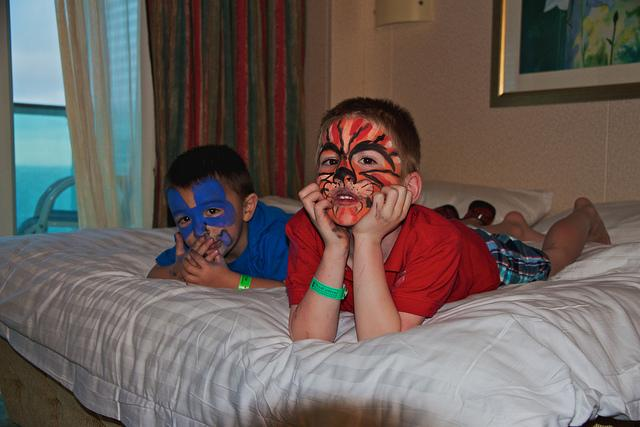Where are these children located? Please explain your reasoning. hotel. They're in a hotel. 